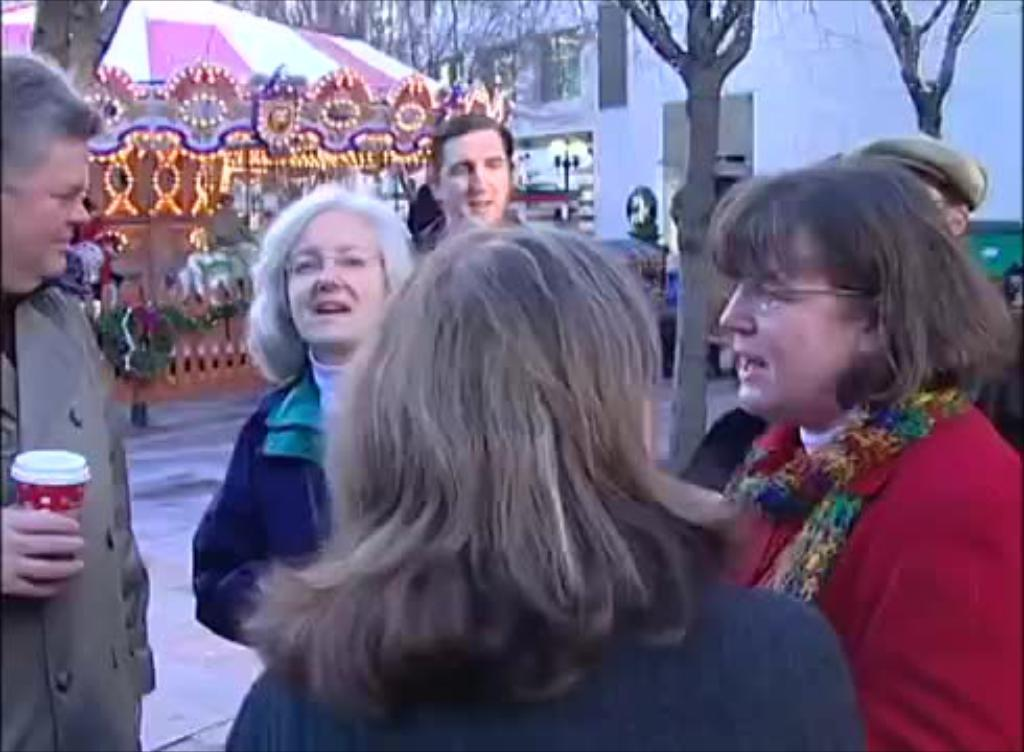How many people are in the image? There is a group of people in the image. What are the people in the image doing? The people are standing on a path. Can you describe what the man in the image is holding? The man is holding a cup. What can be seen in the background of the image? There are trees, buildings, and other unspecified things visible in the background. What type of lunchroom is visible in the image? There is no lunchroom present in the image. Can you tell me if the people in the image have a partner? The image does not provide information about whether the people have partners or not. 